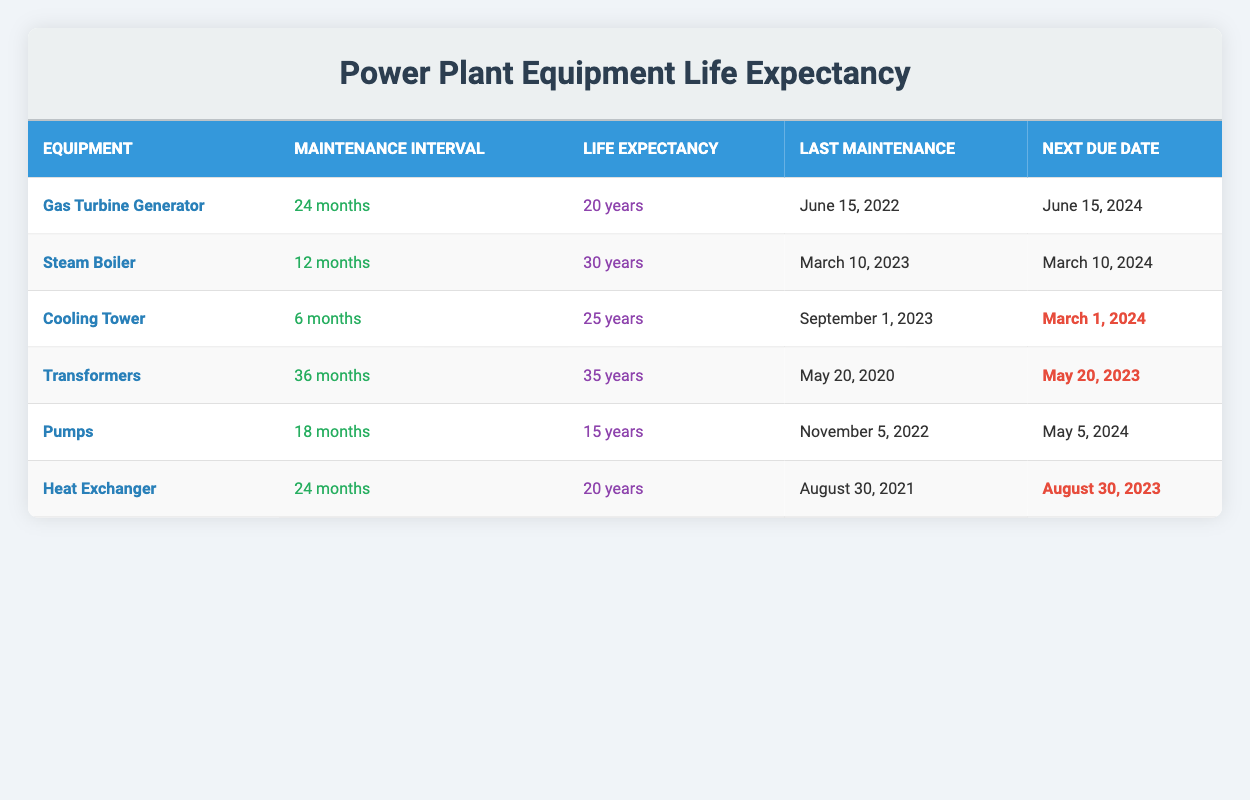What's the maintenance interval for the Cooling Tower? The table shows that the Cooling Tower has a maintenance interval of 6 months listed under the "Maintenance Interval" column.
Answer: 6 months When is the next maintenance due for the Gas Turbine Generator? The table indicates that the next due date for the Gas Turbine Generator is June 15, 2024, in the "Next Due Date" column.
Answer: June 15, 2024 How many years of life expectancy do the Pumps have? According to the data, the Pumps have an estimated life expectancy of 15 years as specified in the "Life Expectancy" column.
Answer: 15 years Which piece of equipment has the longest estimated life expectancy? The Transformers have the longest estimated life expectancy of 35 years, as indicated in the "Life Expectancy" column compared to other equipment.
Answer: 35 years How many months are between the last maintenance date of the Steam Boiler and its next due date? The last maintenance date for the Steam Boiler is March 10, 2023, and the next due date is March 10, 2024. The difference is 12 months, calculated by counting from March to the next March.
Answer: 12 months Is the Cooling Tower maintenance due before the Heat Exchanger maintenance? The Cooling Tower's next maintenance due date is March 1, 2024, and the Heat Exchanger's due date is August 30, 2023. Since August 30, 2023, is earlier than March 1, 2024, the answer is yes.
Answer: Yes What is the average maintenance interval of all the listed equipment? To find the average maintenance interval: (24 + 12 + 6 + 36 + 18 + 24) = 120 months. There are 6 pieces of equipment, so the average is 120/6 = 20 months.
Answer: 20 months Which equipment has the next due maintenance that is marked as due soon? The Cooling Tower and Transformers have maintenance that is due soon, but the Cooling Tower has the nearest upcoming date, March 1, 2024.
Answer: Cooling Tower Does the Steam Boiler require maintenance more frequently than the Gas Turbine Generator? The Steam Boiler has a maintenance interval of 12 months, while the Gas Turbine Generator has an interval of 24 months. Since 12 months is less than 24 months, the answer is yes.
Answer: Yes 